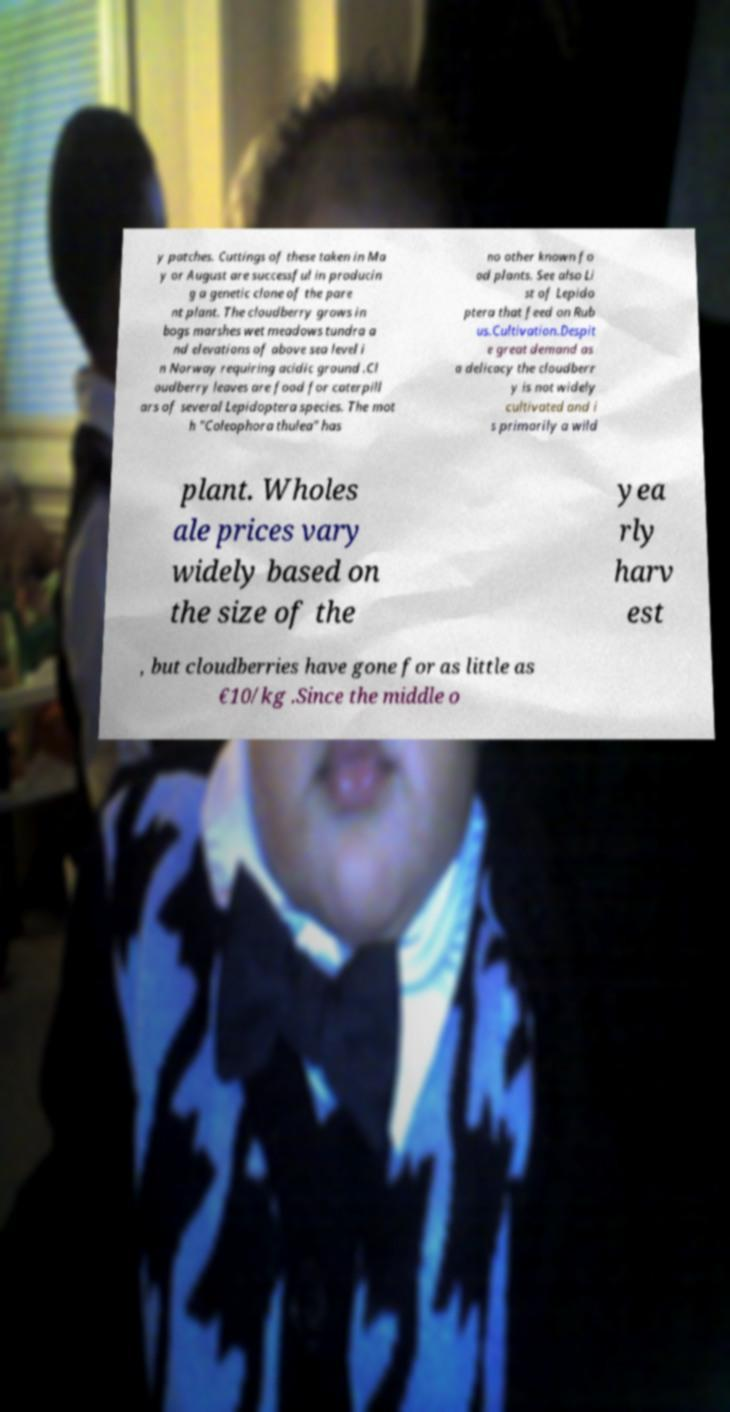Please read and relay the text visible in this image. What does it say? y patches. Cuttings of these taken in Ma y or August are successful in producin g a genetic clone of the pare nt plant. The cloudberry grows in bogs marshes wet meadows tundra a nd elevations of above sea level i n Norway requiring acidic ground .Cl oudberry leaves are food for caterpill ars of several Lepidoptera species. The mot h "Coleophora thulea" has no other known fo od plants. See also Li st of Lepido ptera that feed on Rub us.Cultivation.Despit e great demand as a delicacy the cloudberr y is not widely cultivated and i s primarily a wild plant. Wholes ale prices vary widely based on the size of the yea rly harv est , but cloudberries have gone for as little as €10/kg .Since the middle o 